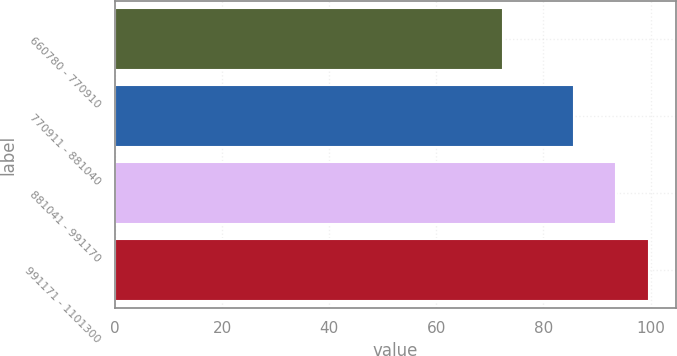<chart> <loc_0><loc_0><loc_500><loc_500><bar_chart><fcel>660780 - 770910<fcel>770911 - 881040<fcel>881041 - 991170<fcel>991171 - 1101300<nl><fcel>72.4<fcel>85.66<fcel>93.53<fcel>99.72<nl></chart> 